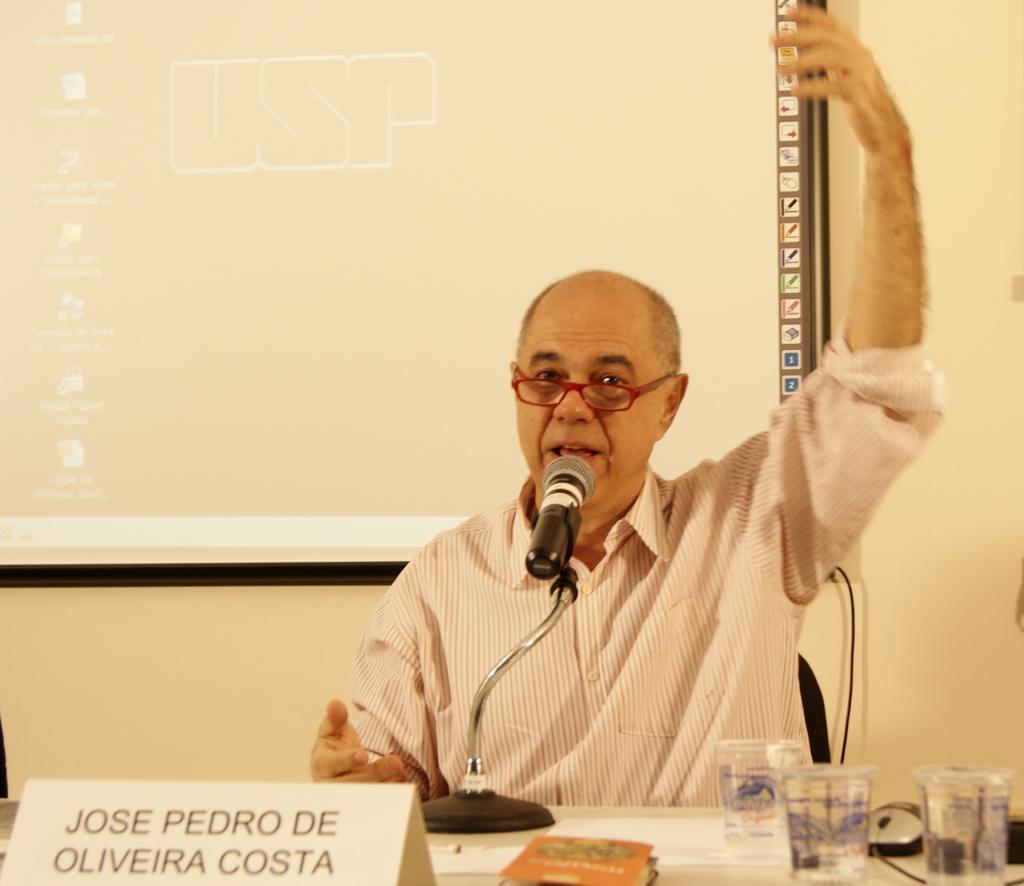Please provide a concise description of this image. In the center of the image we can see person sitting at the table. On the table we can see mic, name board, glasses and book. In the background there is wall and screen. 